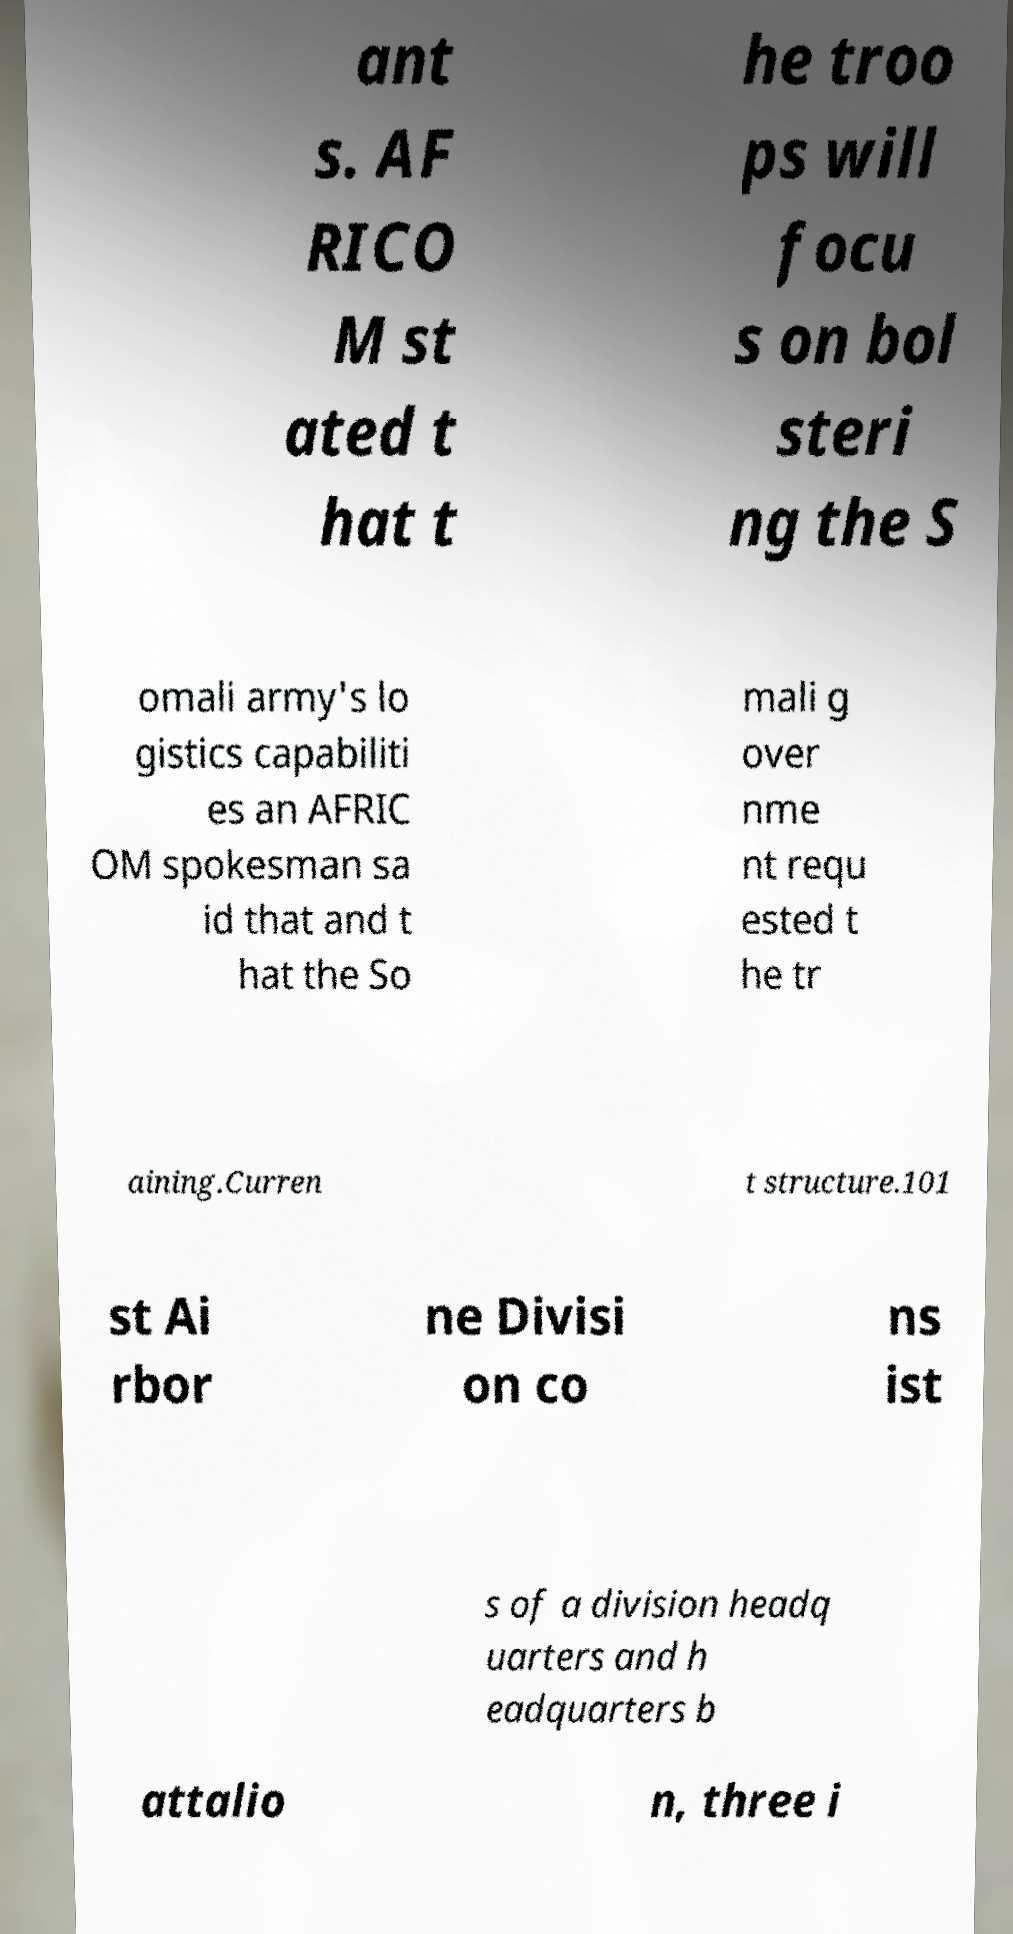Can you accurately transcribe the text from the provided image for me? ant s. AF RICO M st ated t hat t he troo ps will focu s on bol steri ng the S omali army's lo gistics capabiliti es an AFRIC OM spokesman sa id that and t hat the So mali g over nme nt requ ested t he tr aining.Curren t structure.101 st Ai rbor ne Divisi on co ns ist s of a division headq uarters and h eadquarters b attalio n, three i 